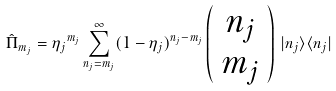Convert formula to latex. <formula><loc_0><loc_0><loc_500><loc_500>\hat { \Pi } _ { m _ { j } } = { \eta _ { j } } ^ { m _ { j } } \sum _ { n _ { j } = m _ { j } } ^ { \infty } ( 1 - \eta _ { j } ) ^ { n _ { j } - m _ { j } } \left ( \begin{array} { c } n _ { j } \\ m _ { j } \end{array} \right ) \, | n _ { j } \rangle \langle n _ { j } |</formula> 